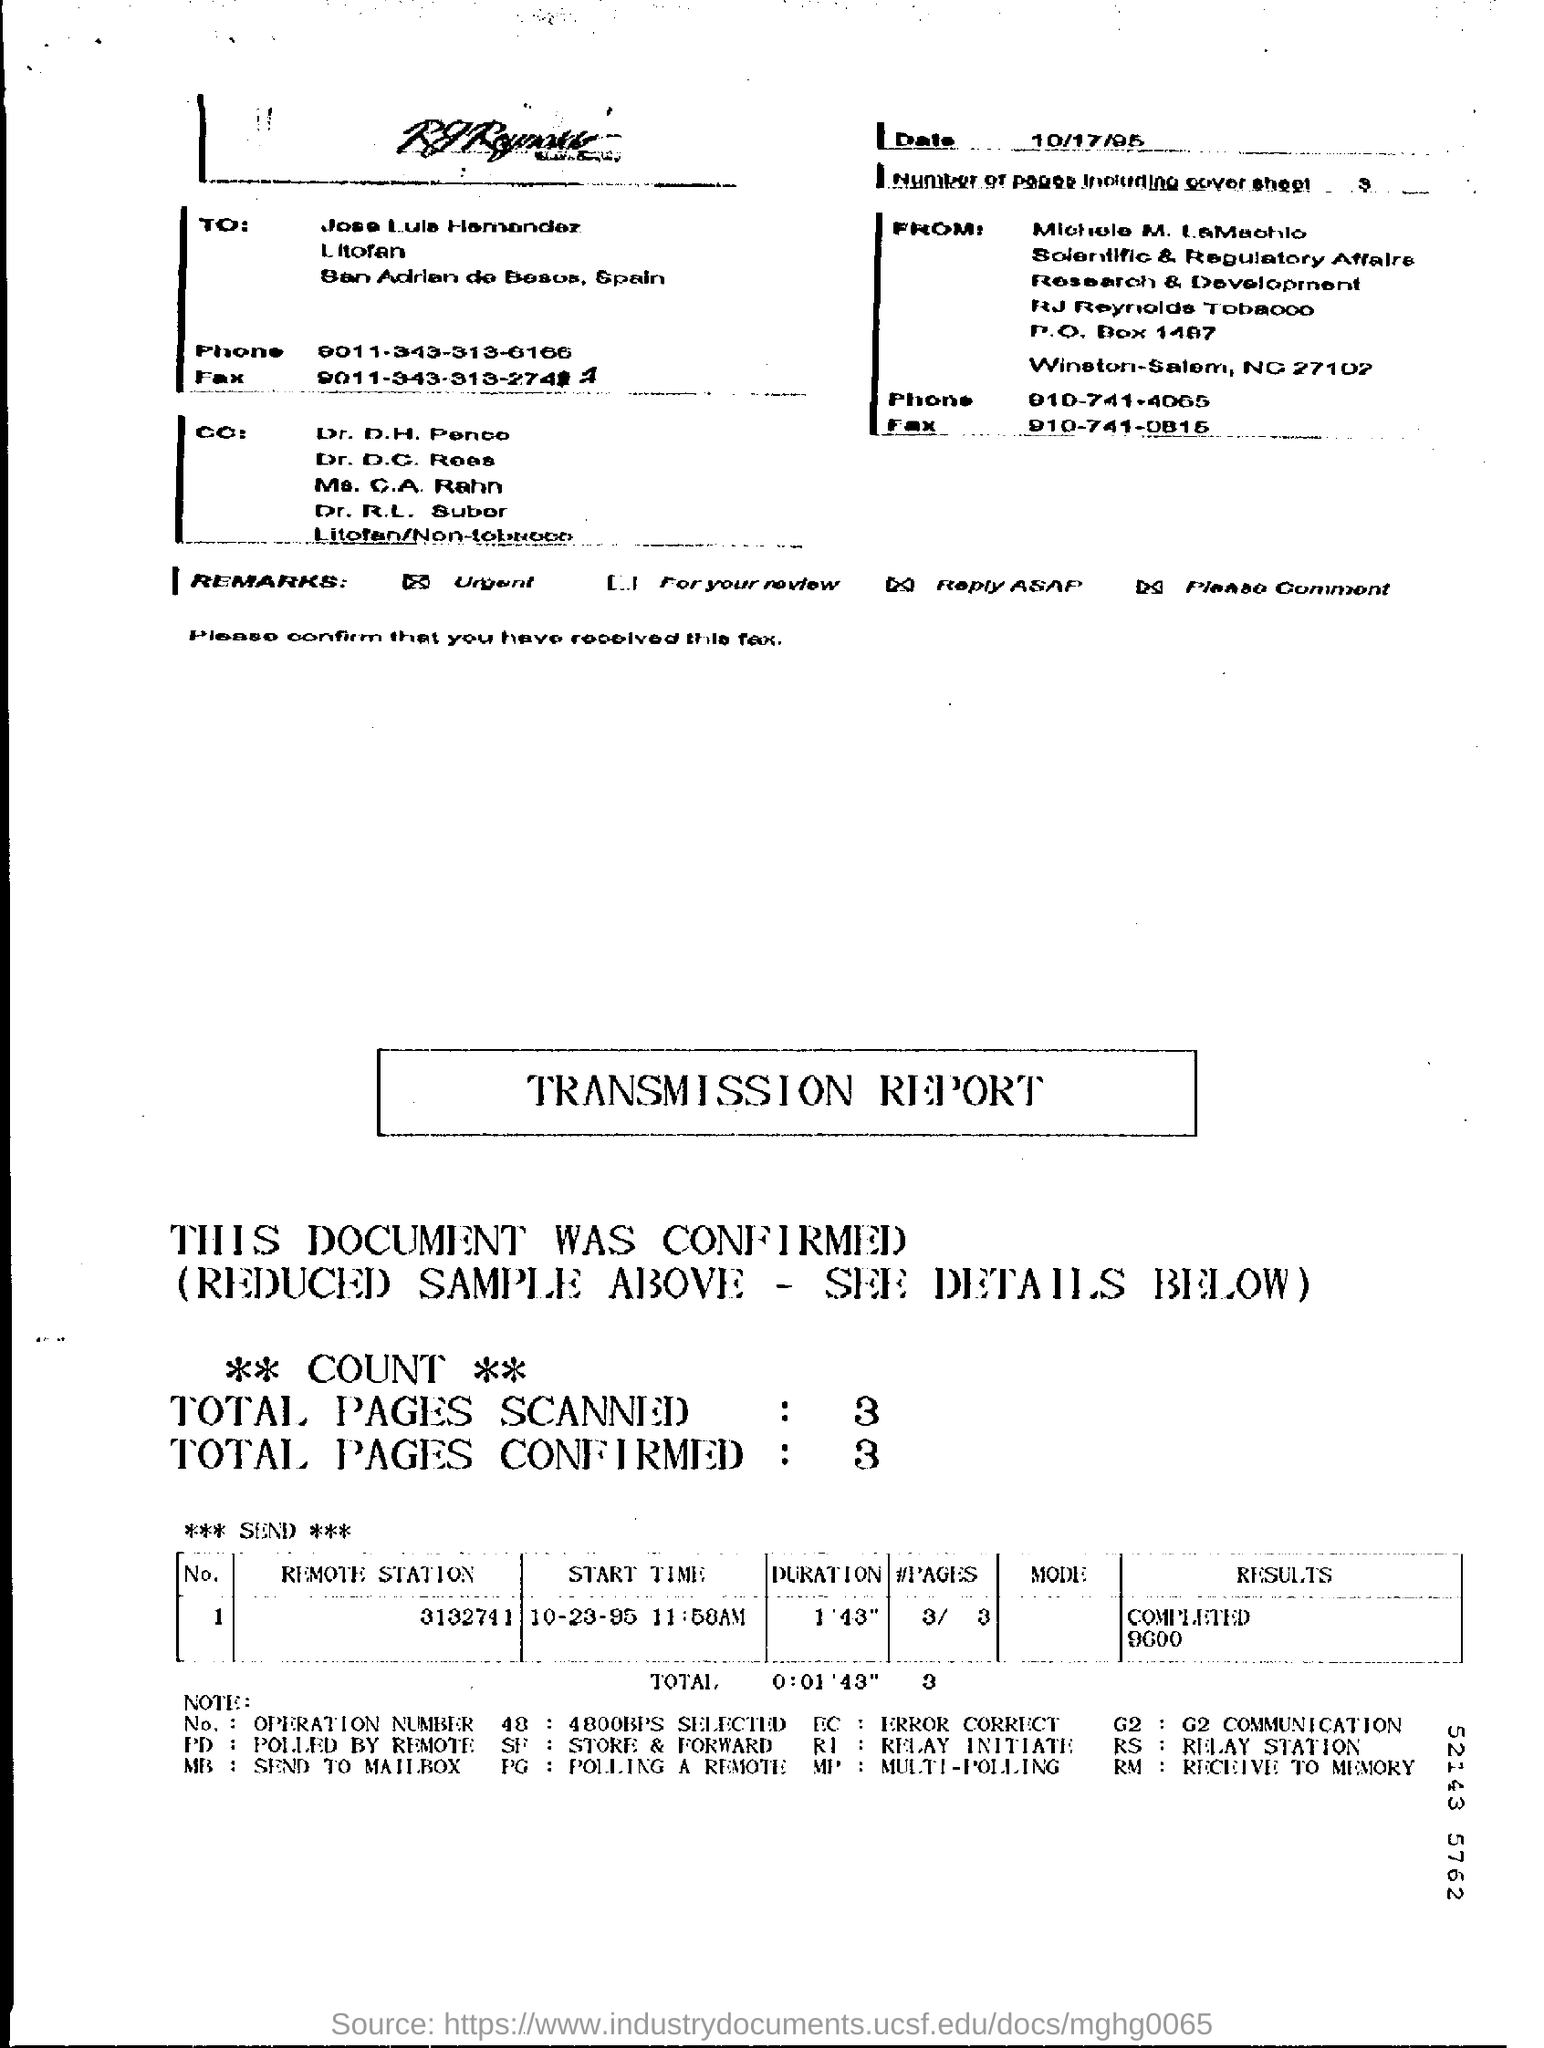What is the Date?
Provide a short and direct response. 10/17/95. What is the fax for Jose Louis Hamandez?
Provide a succinct answer. 9011-343-313-2741. What is the phone for Michelle M. LaMachlo?
Ensure brevity in your answer.  910-741-4065. What is the duration for Remote station 3132741?
Make the answer very short. 1'43". What is the results for Remote station 3132741?
Provide a short and direct response. COMPLETED 9600. 